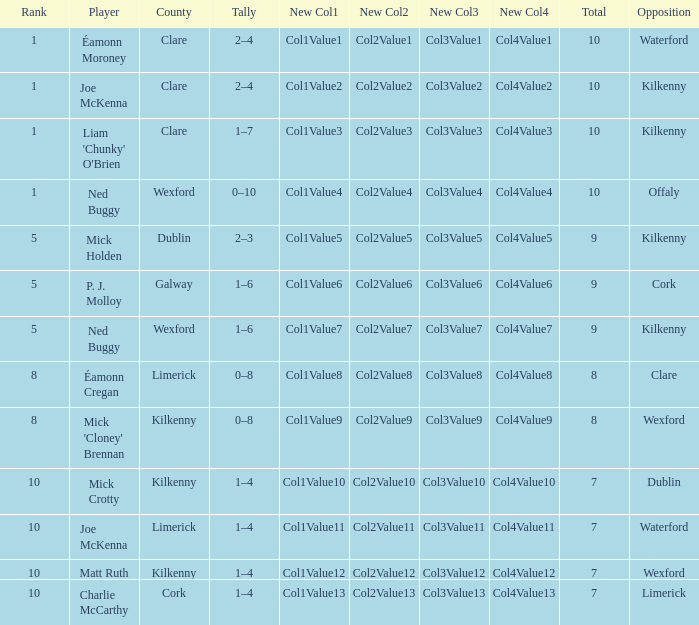Which Total has a County of kilkenny, and a Tally of 1–4, and a Rank larger than 10? None. 